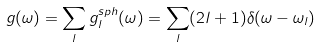Convert formula to latex. <formula><loc_0><loc_0><loc_500><loc_500>g ( \omega ) = \sum _ { l } g ^ { s p h } _ { l } ( \omega ) = \sum _ { l } ( 2 l + 1 ) \delta ( \omega - \omega _ { l } )</formula> 